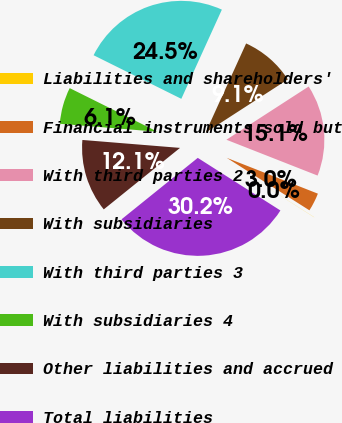<chart> <loc_0><loc_0><loc_500><loc_500><pie_chart><fcel>Liabilities and shareholders'<fcel>Financial instruments sold but<fcel>With third parties 2<fcel>With subsidiaries<fcel>With third parties 3<fcel>With subsidiaries 4<fcel>Other liabilities and accrued<fcel>Total liabilities<nl><fcel>0.02%<fcel>3.04%<fcel>15.1%<fcel>9.07%<fcel>24.45%<fcel>6.05%<fcel>12.09%<fcel>30.18%<nl></chart> 